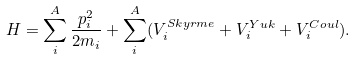Convert formula to latex. <formula><loc_0><loc_0><loc_500><loc_500>H = \sum _ { i } ^ { A } { \frac { { p } _ { i } ^ { 2 } } { 2 m _ { i } } } + \sum _ { i } ^ { A } ( { V _ { i } ^ { S k y r m e } + V _ { i } ^ { Y u k } + V _ { i } ^ { C o u l } } ) .</formula> 